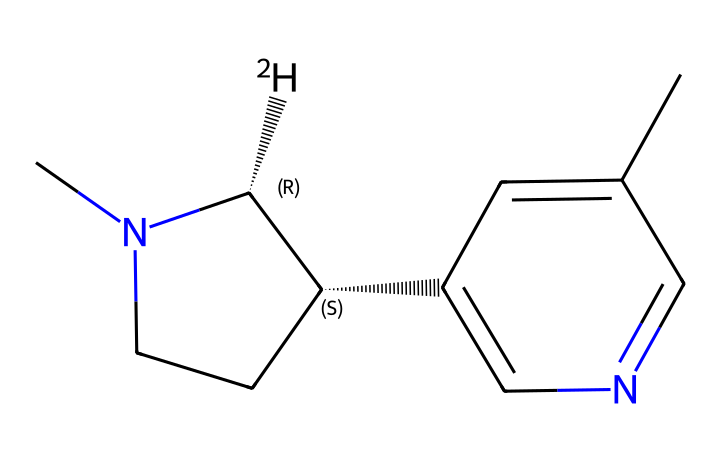What is the molecular formula for nicotine-d4? To determine the molecular formula, count the number of carbon (C), hydrogen (H), nitrogen (N) atoms in the SMILES representation. The structure shows 10 carbons, 12 hydrogens (including deuterated hydrogens), and 2 nitrogens. Therefore, the molecular formula is C10H12N2.
Answer: C10H12N2 How many rings are present in the structure? Analyzing the SMILES string shows two numbered rings, labeled as 1 and 2, indicating that there are two cyclic structures in the compound.
Answer: 2 What type of molecule is nicotine-d4 classified as? The presence of nitrogen atoms and its structure signifies that it belongs to the alkaloid class, which are naturally occurring compounds often found in plants and known for their physiological effects.
Answer: alkaloid What is the total number of deuterated hydrogens in nicotine-d4? In the SMILES, each '[2H]' indicates a deuterium atom, which substitutes for a regular hydrogen atom. There is one '[2H]' present, indicating there is one deuterated hydrogen in the molecule.
Answer: 1 Which part of the molecule contains the nitrogen atoms? In the SMILES representation, the nitrogen atoms are denoted by 'N' which are included in the ring structure; specifically, they appear at the position of the fused rings in the overall structure.
Answer: ring structure What is the significance of deuteration in addiction studies? Deuteration (replacement of hydrogen with deuterium) alters the isotopic composition, which can help trace the metabolism and distribution of nicotine in the body, providing clearer data in addiction studies.
Answer: clearer data 